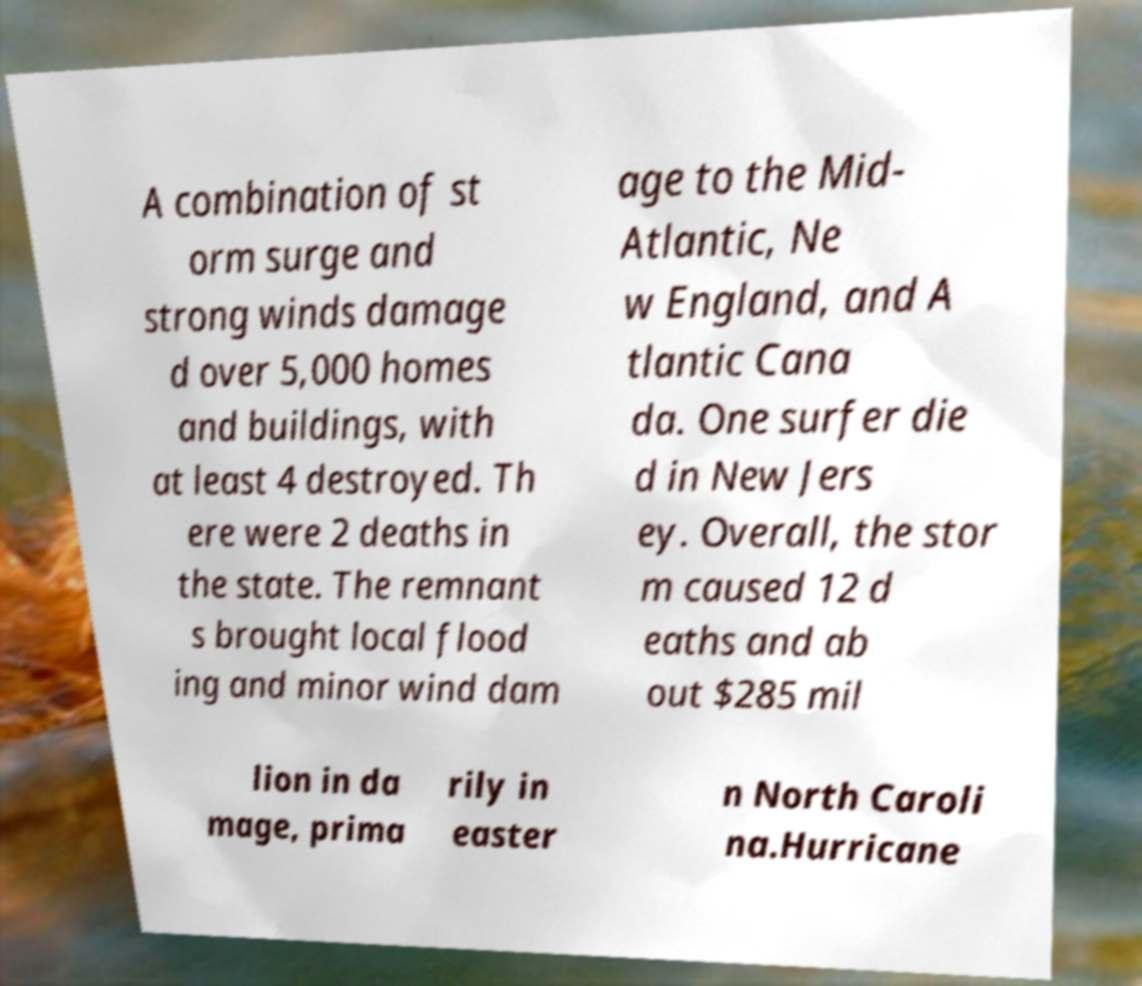Please read and relay the text visible in this image. What does it say? A combination of st orm surge and strong winds damage d over 5,000 homes and buildings, with at least 4 destroyed. Th ere were 2 deaths in the state. The remnant s brought local flood ing and minor wind dam age to the Mid- Atlantic, Ne w England, and A tlantic Cana da. One surfer die d in New Jers ey. Overall, the stor m caused 12 d eaths and ab out $285 mil lion in da mage, prima rily in easter n North Caroli na.Hurricane 